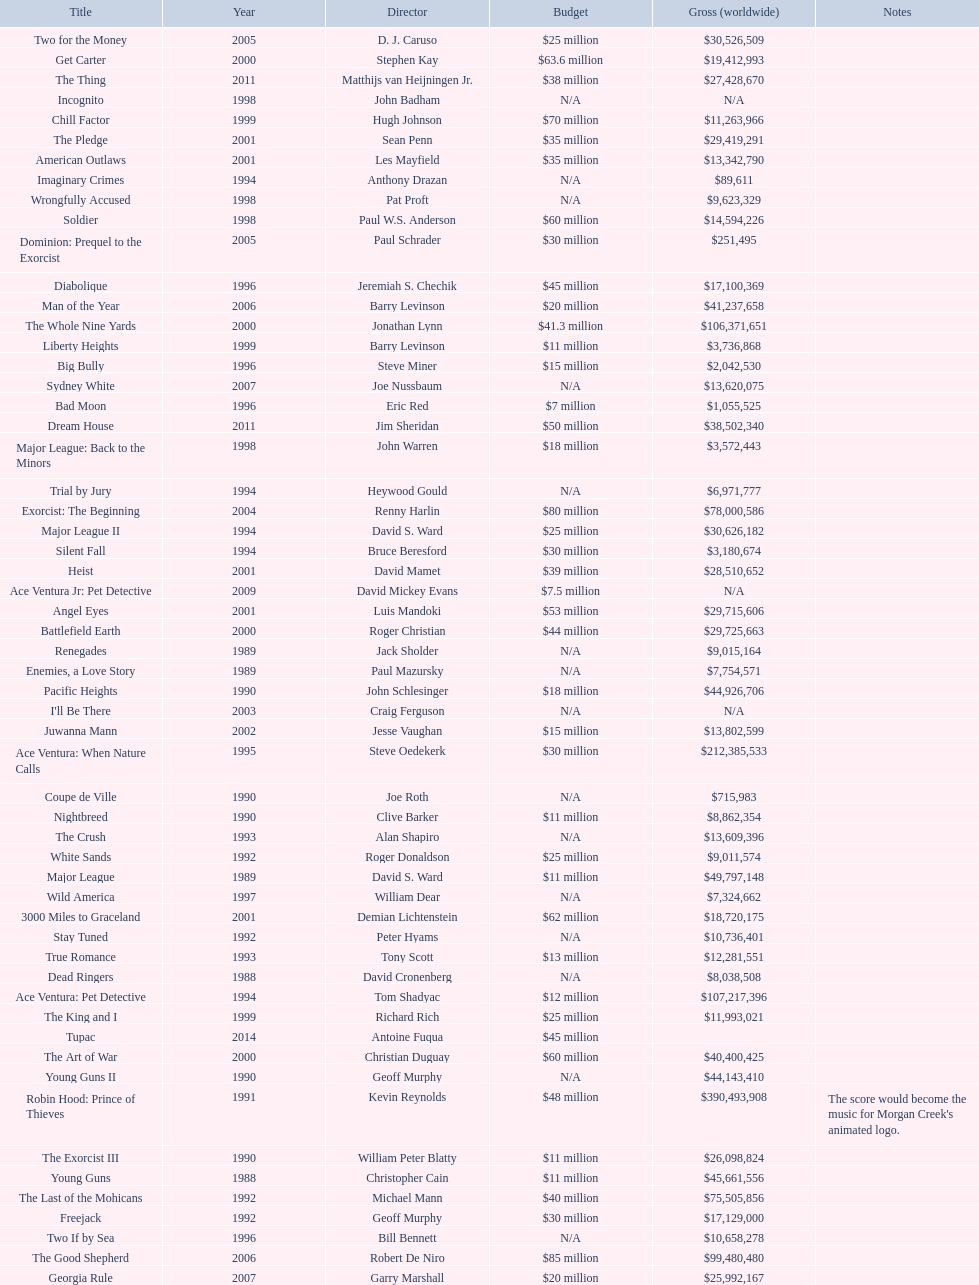Which morgan creek film grossed the most worldwide? Robin Hood: Prince of Thieves. 